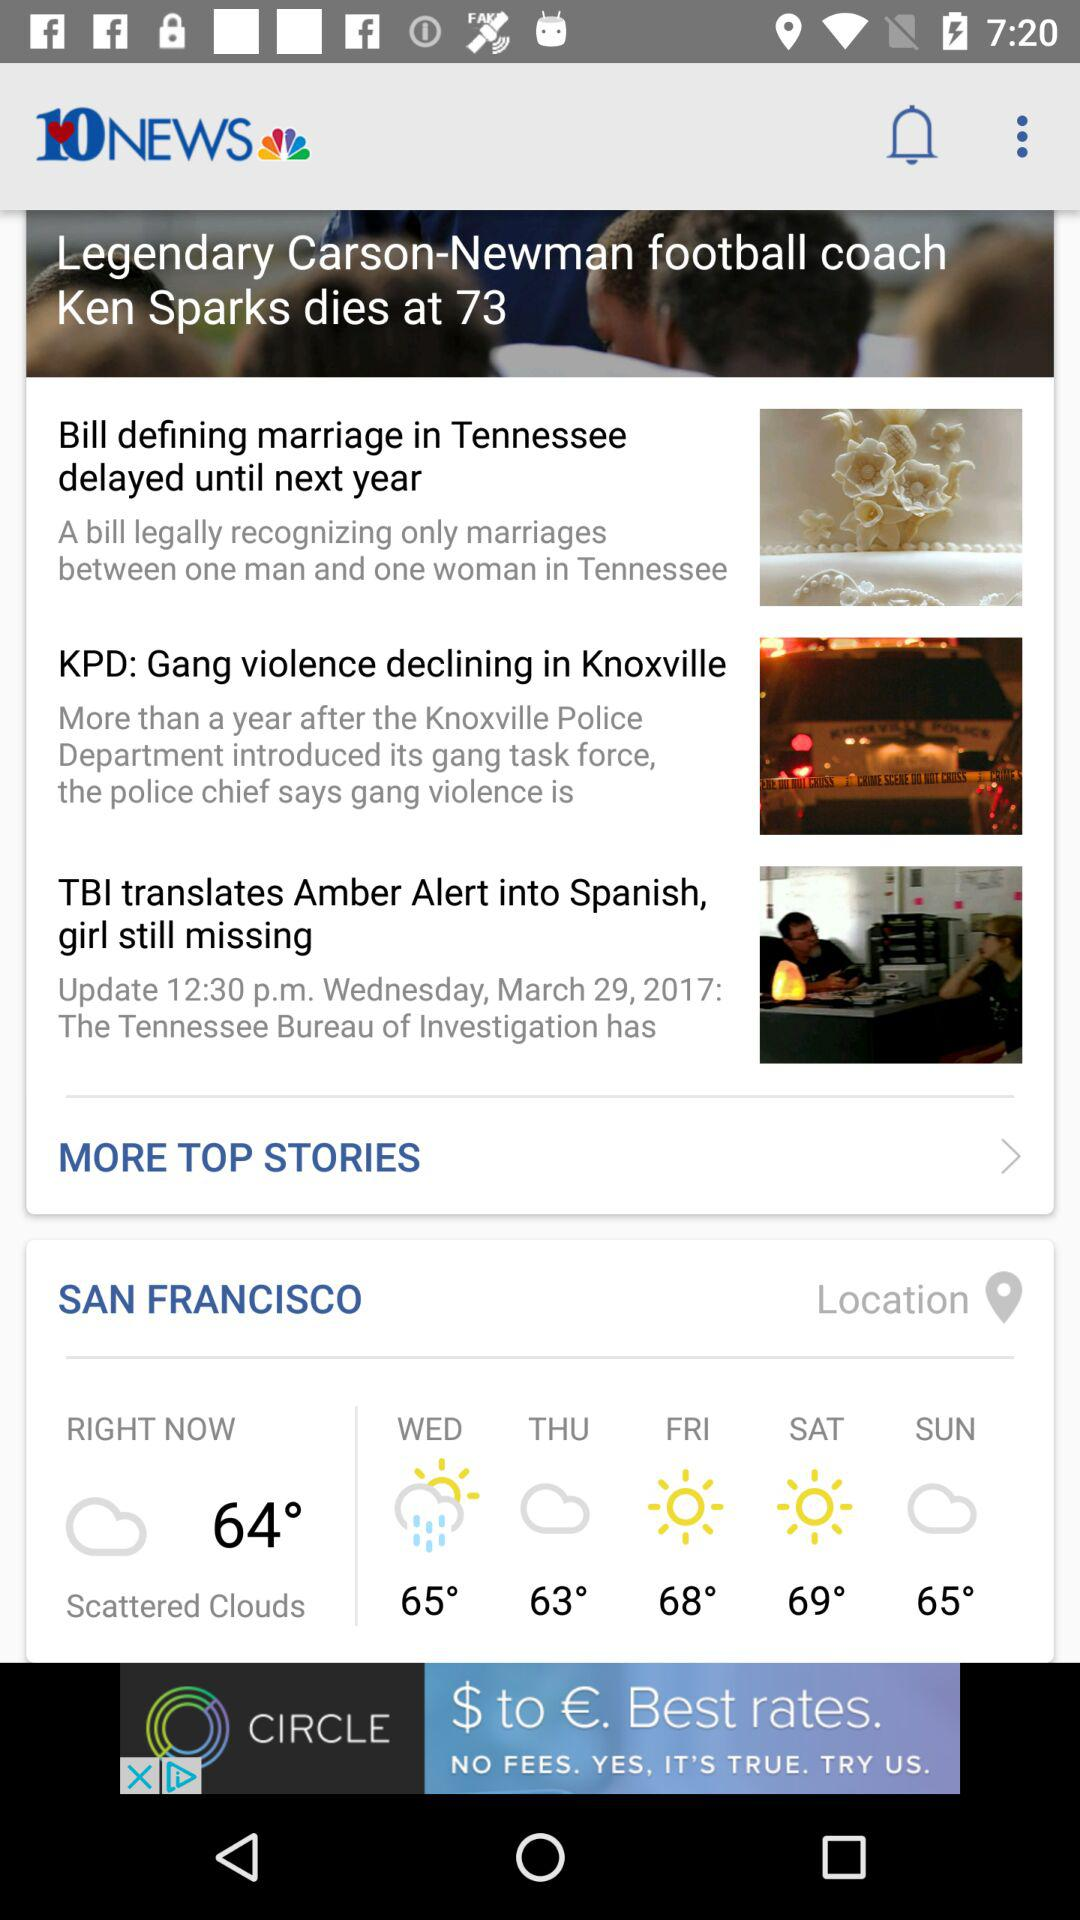How is the weather right now? The weather is "Scattered Clouds". 